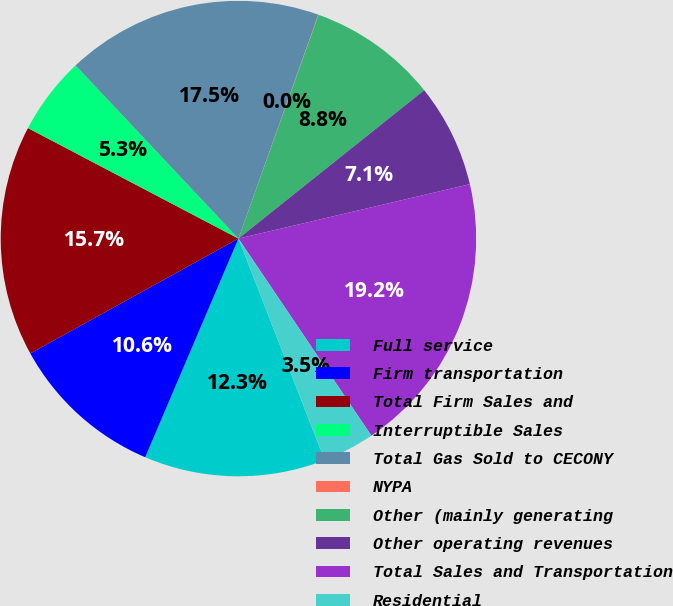Convert chart. <chart><loc_0><loc_0><loc_500><loc_500><pie_chart><fcel>Full service<fcel>Firm transportation<fcel>Total Firm Sales and<fcel>Interruptible Sales<fcel>Total Gas Sold to CECONY<fcel>NYPA<fcel>Other (mainly generating<fcel>Other operating revenues<fcel>Total Sales and Transportation<fcel>Residential<nl><fcel>12.32%<fcel>10.56%<fcel>15.72%<fcel>5.29%<fcel>17.47%<fcel>0.02%<fcel>8.8%<fcel>7.05%<fcel>19.23%<fcel>3.54%<nl></chart> 